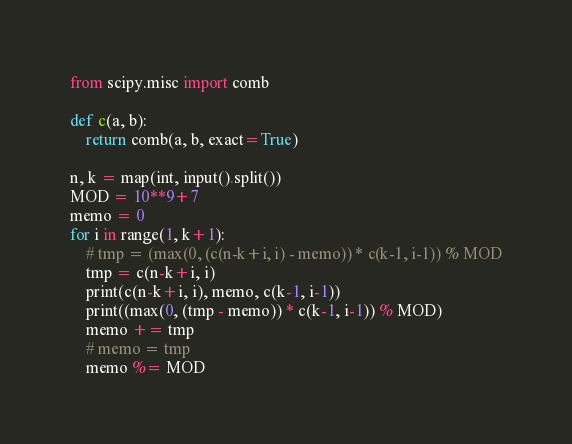<code> <loc_0><loc_0><loc_500><loc_500><_Python_>from scipy.misc import comb

def c(a, b):
    return comb(a, b, exact=True)

n, k = map(int, input().split())
MOD = 10**9+7
memo = 0
for i in range(1, k+1):
    # tmp = (max(0, (c(n-k+i, i) - memo)) * c(k-1, i-1)) % MOD
    tmp = c(n-k+i, i)
    print(c(n-k+i, i), memo, c(k-1, i-1))
    print((max(0, (tmp - memo)) * c(k-1, i-1)) % MOD)
    memo += tmp
    # memo = tmp
    memo %= MOD
</code> 